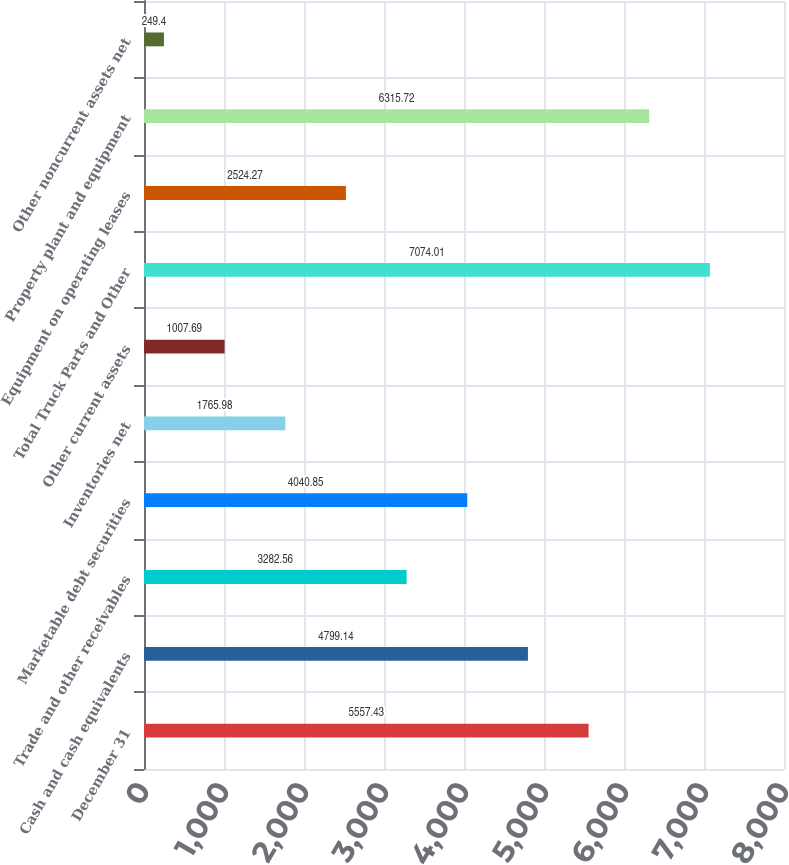<chart> <loc_0><loc_0><loc_500><loc_500><bar_chart><fcel>December 31<fcel>Cash and cash equivalents<fcel>Trade and other receivables<fcel>Marketable debt securities<fcel>Inventories net<fcel>Other current assets<fcel>Total Truck Parts and Other<fcel>Equipment on operating leases<fcel>Property plant and equipment<fcel>Other noncurrent assets net<nl><fcel>5557.43<fcel>4799.14<fcel>3282.56<fcel>4040.85<fcel>1765.98<fcel>1007.69<fcel>7074.01<fcel>2524.27<fcel>6315.72<fcel>249.4<nl></chart> 